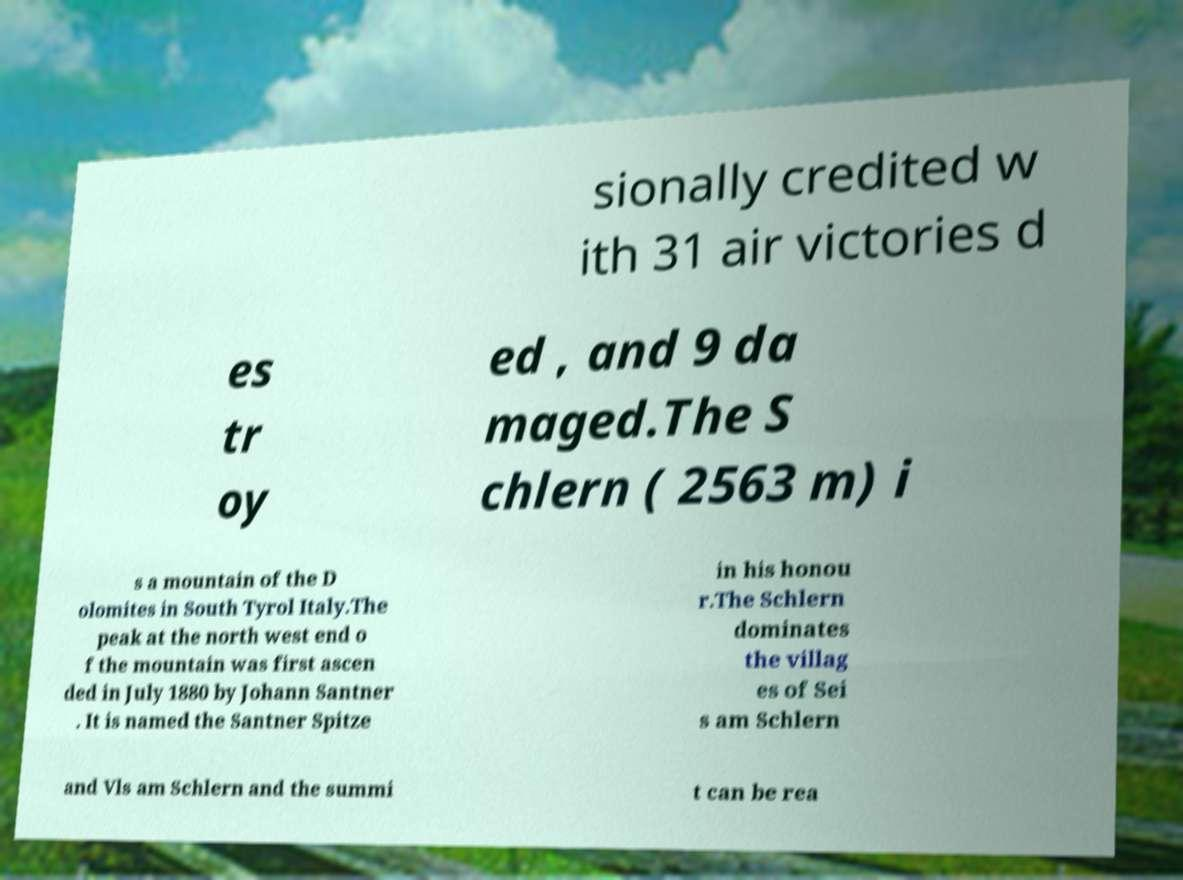Can you read and provide the text displayed in the image?This photo seems to have some interesting text. Can you extract and type it out for me? sionally credited w ith 31 air victories d es tr oy ed , and 9 da maged.The S chlern ( 2563 m) i s a mountain of the D olomites in South Tyrol Italy.The peak at the north west end o f the mountain was first ascen ded in July 1880 by Johann Santner . It is named the Santner Spitze in his honou r.The Schlern dominates the villag es of Sei s am Schlern and Vls am Schlern and the summi t can be rea 